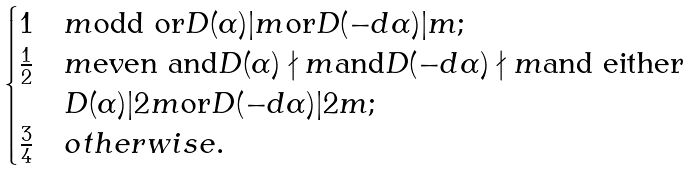Convert formula to latex. <formula><loc_0><loc_0><loc_500><loc_500>\begin{cases} 1 & m \text {odd or} D ( \alpha ) | m \text {or} D ( - d \alpha ) | m ; \\ \frac { 1 } { 2 } & m \text {even and} D ( \alpha ) \nmid m \text {and} D ( - d \alpha ) \nmid m \text {and either} \\ & D ( \alpha ) | 2 m \text {or} D ( - d \alpha ) | 2 m ; \\ \frac { 3 } { 4 } & o t h e r w i s e . \end{cases}</formula> 